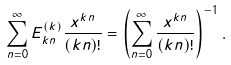<formula> <loc_0><loc_0><loc_500><loc_500>\sum _ { n = 0 } ^ { \infty } E _ { k n } ^ { ( k ) } \frac { x ^ { k n } } { ( k n ) ! } = \left ( \sum _ { n = 0 } ^ { \infty } \frac { x ^ { k n } } { ( k n ) ! } \right ) ^ { - 1 } .</formula> 